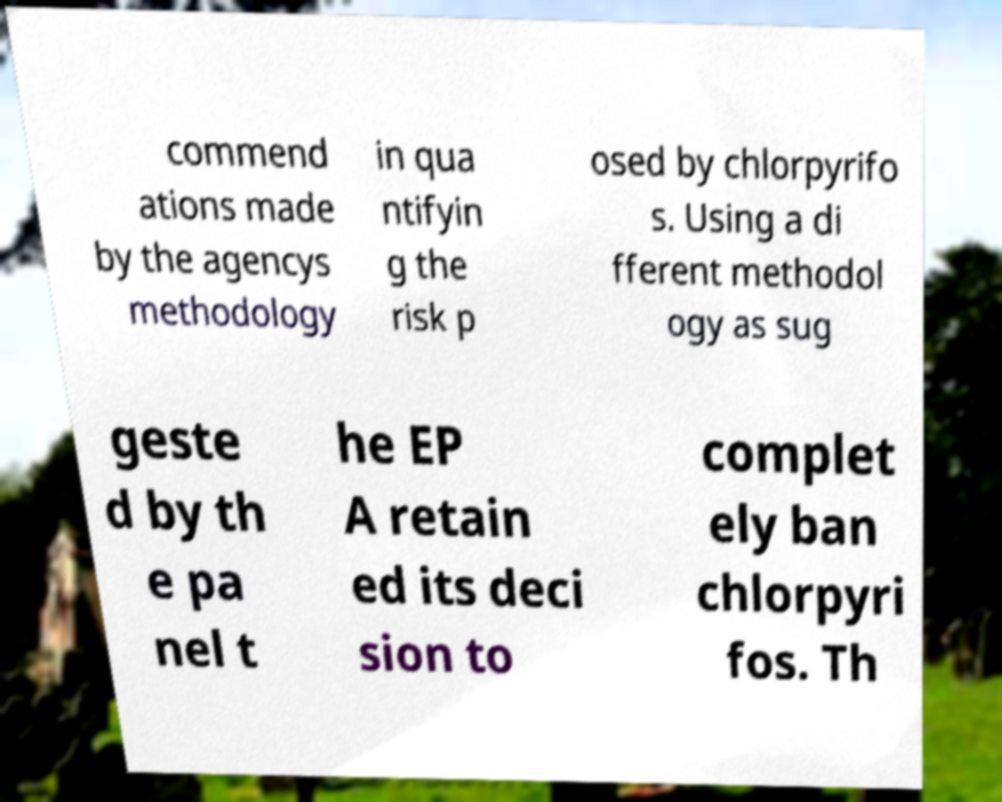I need the written content from this picture converted into text. Can you do that? commend ations made by the agencys methodology in qua ntifyin g the risk p osed by chlorpyrifo s. Using a di fferent methodol ogy as sug geste d by th e pa nel t he EP A retain ed its deci sion to complet ely ban chlorpyri fos. Th 